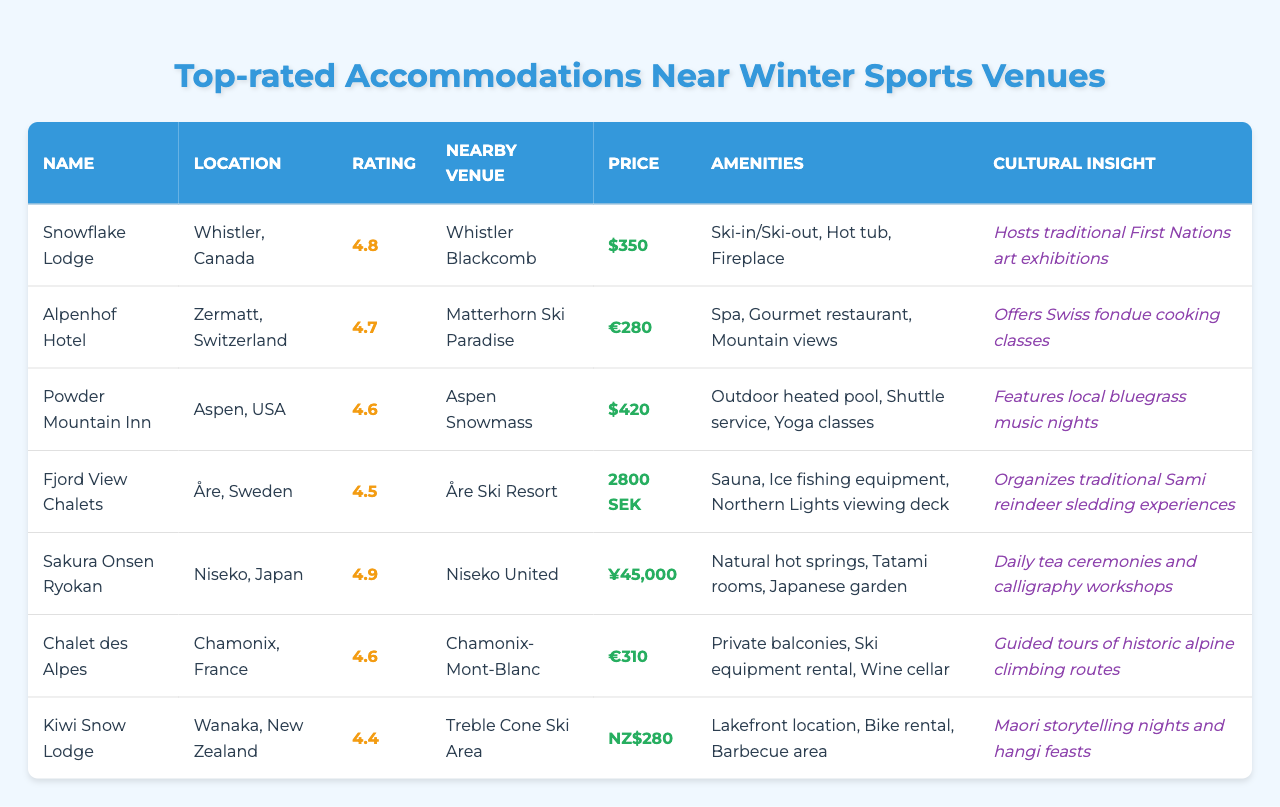What is the highest rating among the accommodations? The ratings listed are 4.8 (Snowflake Lodge), 4.7 (Alpenhof Hotel), 4.6 (Powder Mountain Inn, Chalet des Alpes), 4.5 (Fjord View Chalets), 4.9 (Sakura Onsen Ryokan), and 4.4 (Kiwi Snow Lodge). The highest rating among these is 4.9.
Answer: 4.9 Which accommodation is located in Niseko, Japan? Referring to the table, the accommodation listed for Niseko, Japan, is Sakura Onsen Ryokan.
Answer: Sakura Onsen Ryokan What are the amenities offered at Powder Mountain Inn? For Powder Mountain Inn, the table lists outdoor heated pool, shuttle service, and yoga classes as amenities.
Answer: Outdoor heated pool, shuttle service, yoga classes Is there any accommodation that offers ski-in/ski-out access? The Snowflake Lodge is specifically noted for having ski-in/ski-out access among its amenities.
Answer: Yes What is the price difference between the accommodation with the highest rating and the one with the lowest rating? The highest-rated accommodation (Sakura Onsen Ryokan) costs ¥45,000, while the lowest-rated accommodation (Kiwi Snow Lodge) costs NZ$280. To find the difference, we need to convert currencies. Assuming ¥45,000 is approximately NZ$525, the price difference is ¥45,000 - NZ$280 = NZ$245 (approximately).
Answer: Approximately NZ$245 Which accommodations offer cultural insights relating to food? Looking at the cultural insights, Alpenhof Hotel offers Swiss fondue cooking classes and Kiwi Snow Lodge features Maori storytelling nights and hangi feasts.
Answer: Alpenhof Hotel, Kiwi Snow Lodge How many accommodations have a rating above 4.6? The accommodations with ratings above 4.6 are Snowflake Lodge (4.8), Alpenhof Hotel (4.7), and Sakura Onsen Ryokan (4.9). This sums up to three accommodations.
Answer: 3 What is the average price of the accommodations in Euros? Converting all prices to Euros for calculation: Snowflake Lodge ($350 ≈ €320), Alpenhof Hotel (€280), Powder Mountain Inn ($420 ≈ €380), Fjord View Chalets (2800 SEK ≈ €240), Sakura Onsen Ryokan (¥45,000 ≈ €350), Chalet des Alpes (€310), and Kiwi Snow Lodge (NZ$280 ≈ €160). Adding these gives €320 + €280 + €380 + €240 + €350 + €310 + €160 = €2040, divided by 7 gives an average of €291.43.
Answer: €291.43 Are there any accommodations that provide a wellness experience? Yes, both Alpenhof Hotel (which has a spa) and Powder Mountain Inn (which offers yoga classes) provide wellness experiences.
Answer: Yes 